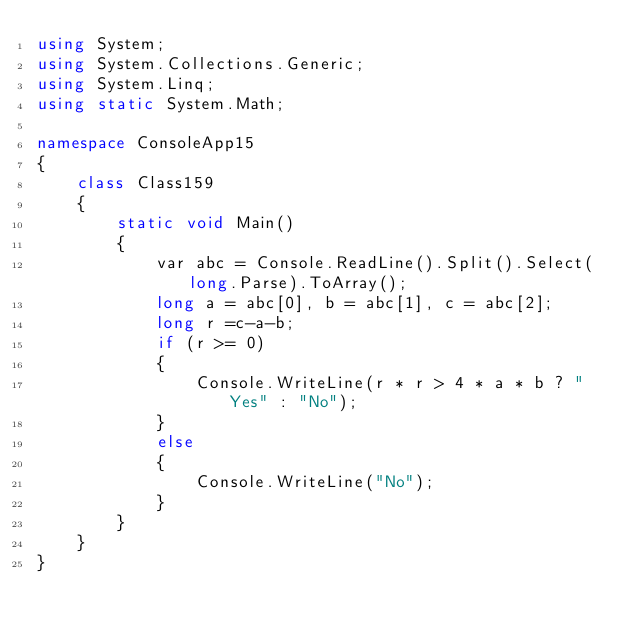<code> <loc_0><loc_0><loc_500><loc_500><_C#_>using System;
using System.Collections.Generic;
using System.Linq;
using static System.Math;

namespace ConsoleApp15
{
    class Class159
    {
        static void Main()
        {
            var abc = Console.ReadLine().Split().Select(long.Parse).ToArray();
            long a = abc[0], b = abc[1], c = abc[2];
            long r =c-a-b;
            if (r >= 0)
            {
                Console.WriteLine(r * r > 4 * a * b ? "Yes" : "No");
            }
            else
            {
                Console.WriteLine("No");
            }
        }
    }
}
</code> 